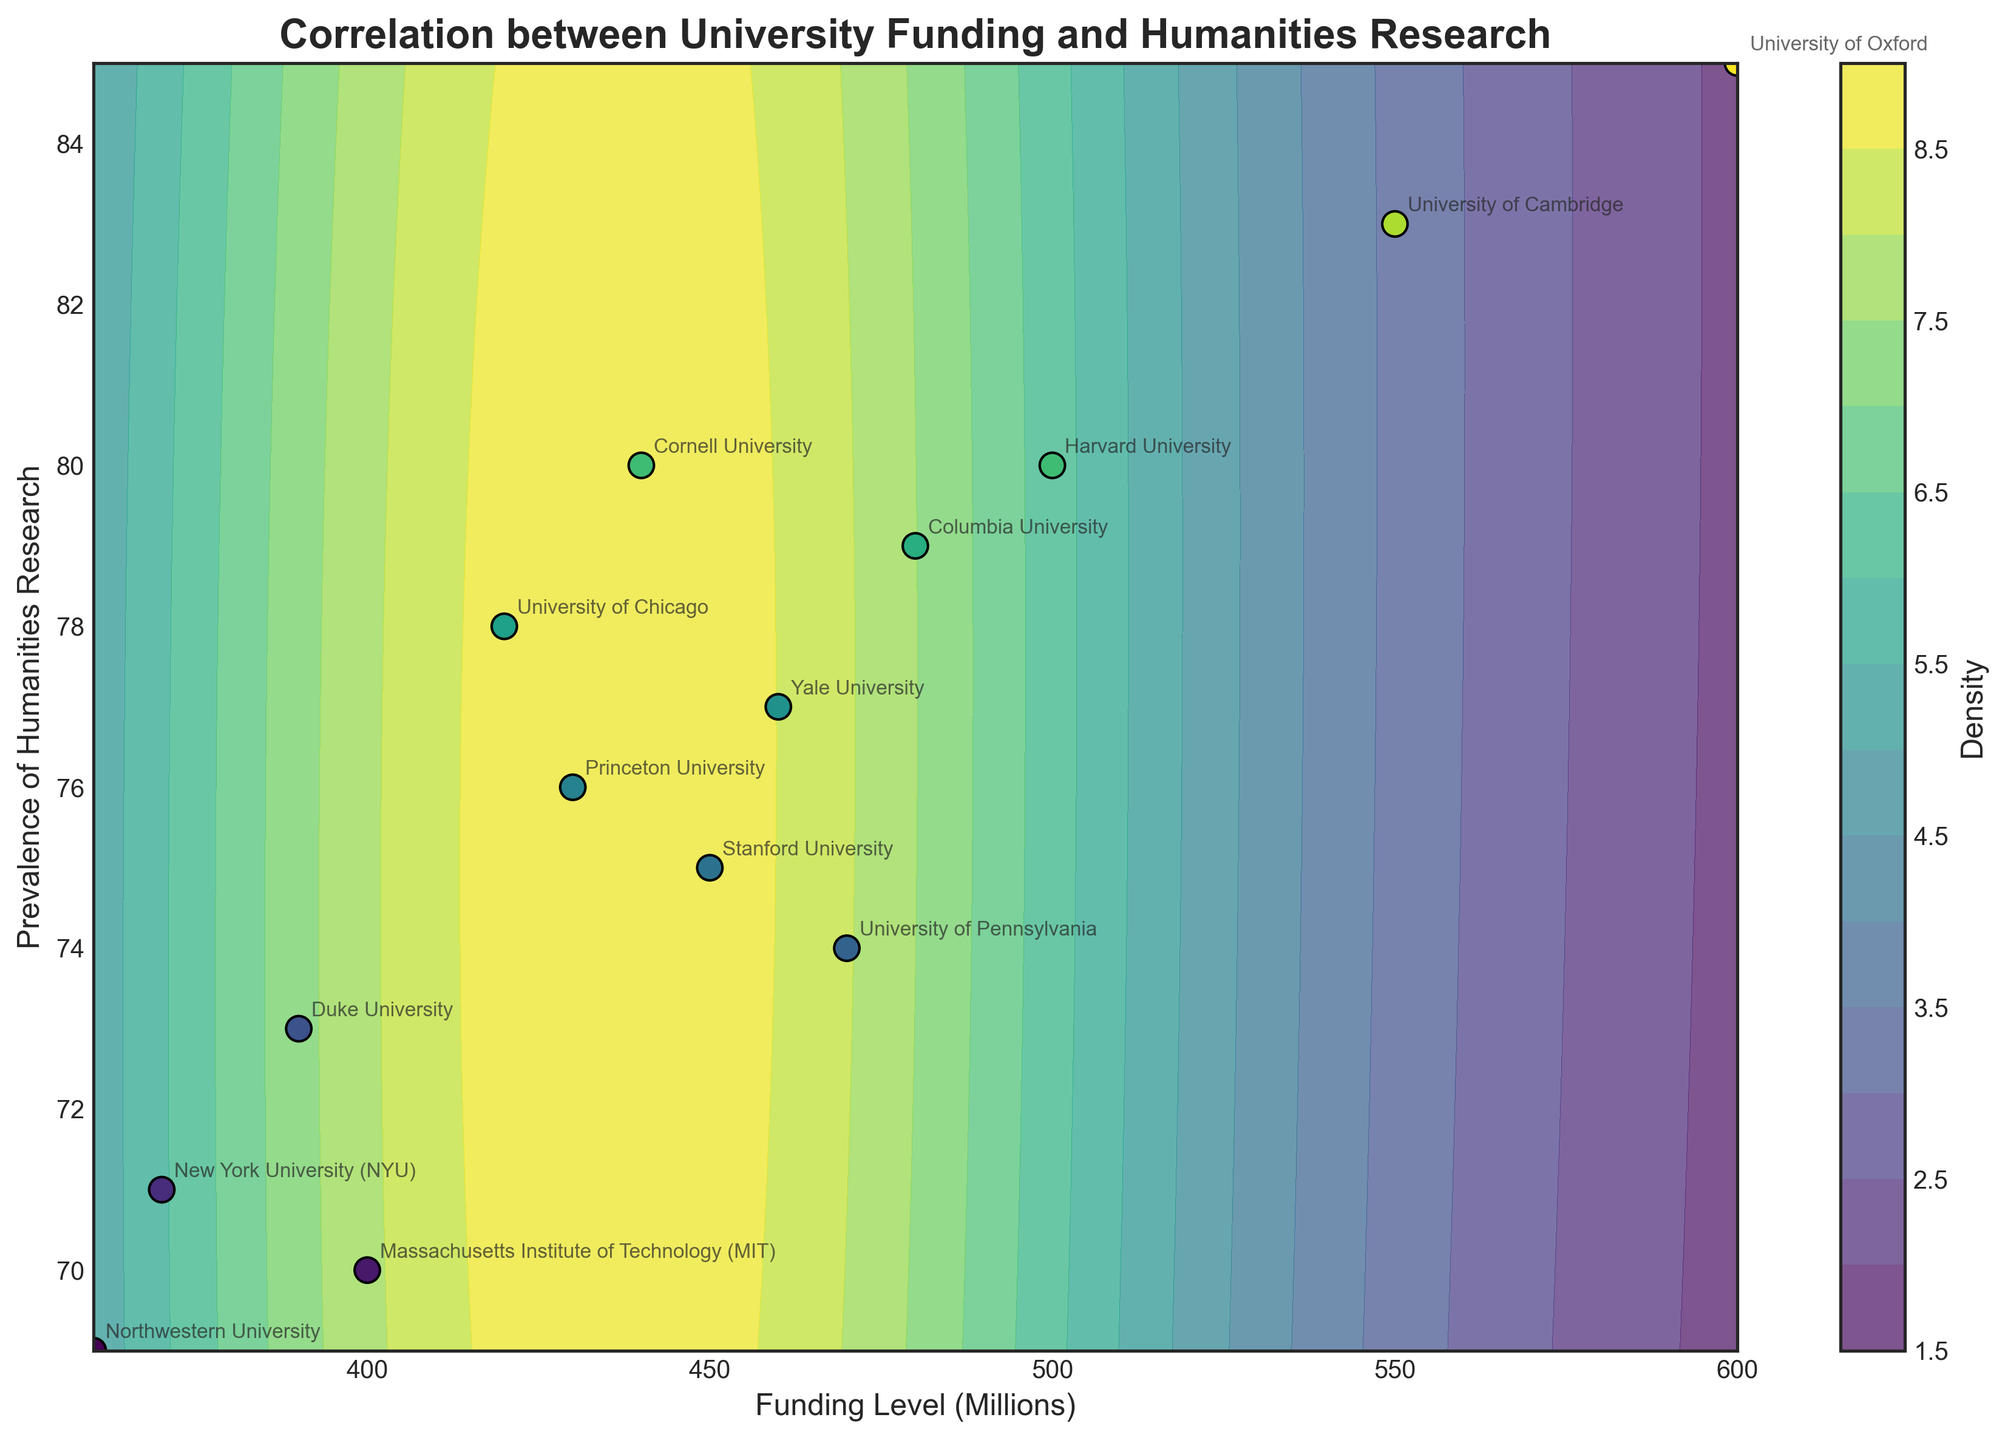What is the title of the plot? The title of the plot is written at the top of the figure and provides a brief description of the plot's focus.
Answer: Correlation between University Funding and Humanities Research What are the labels for the x-axis and y-axis? The labels for the axes are located along the respective x and y axes. They describe what each axis represents.
Answer: Funding Level (Millions) and Prevalence of Humanities Research How many universities are represented in the figure? The number of unique labels in the plot that correspond to universities indicates how many data points, or universities, are included. Counting these labels will give the answer.
Answer: 14 Which university has the highest funding level? By locating the peak position on the x-axis and identifying the label associated with that position, we can determine which university has the highest funding level.
Answer: University of Oxford How does the prevalence of humanities research at Yale University compare to Princeton University? By finding Princeton University and Yale University on the plot and comparing their positions along the y-axis, we can determine which has a higher value.
Answer: Yale University has a higher prevalence What is the trend between funding level and prevalence of humanities research as indicated by the contour plot? The overall pattern can be interpreted by observing the gradient and shapes of the filled contours to discern a relationship. In general terms, this shows increasing or decreasing trends.
Answer: Positive correlation Which university has the highest prevalence of humanities research? By finding the university that appears at the topmost position on the y-axis, we can determine which has the highest prevalence.
Answer: University of Oxford What can be inferred about the density of universities in terms of funding and prevalence of humanities research? The density of the data points is represented by the level and color of the contours. Denser areas will have darker or more concentrated contour patterns.
Answer: Densest in mid funding levels and mid-to-high prevalence Identify one university with a lower funding level that still has a high prevalence of humanities research By looking at universities with lower positions on the x-axis but higher on the y-axis, we can identify examples.
Answer: University of Chicago How many levels are used in the contour plot? The number of discrete color boundaries or contour lines visible can be counted to determine the levels used in the plot.
Answer: 15 